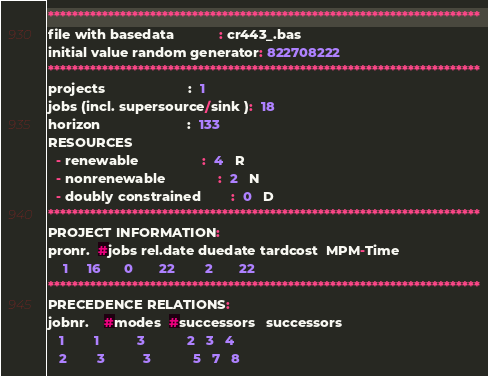Convert code to text. <code><loc_0><loc_0><loc_500><loc_500><_ObjectiveC_>************************************************************************
file with basedata            : cr443_.bas
initial value random generator: 822708222
************************************************************************
projects                      :  1
jobs (incl. supersource/sink ):  18
horizon                       :  133
RESOURCES
  - renewable                 :  4   R
  - nonrenewable              :  2   N
  - doubly constrained        :  0   D
************************************************************************
PROJECT INFORMATION:
pronr.  #jobs rel.date duedate tardcost  MPM-Time
    1     16      0       22        2       22
************************************************************************
PRECEDENCE RELATIONS:
jobnr.    #modes  #successors   successors
   1        1          3           2   3   4
   2        3          3           5   7   8</code> 